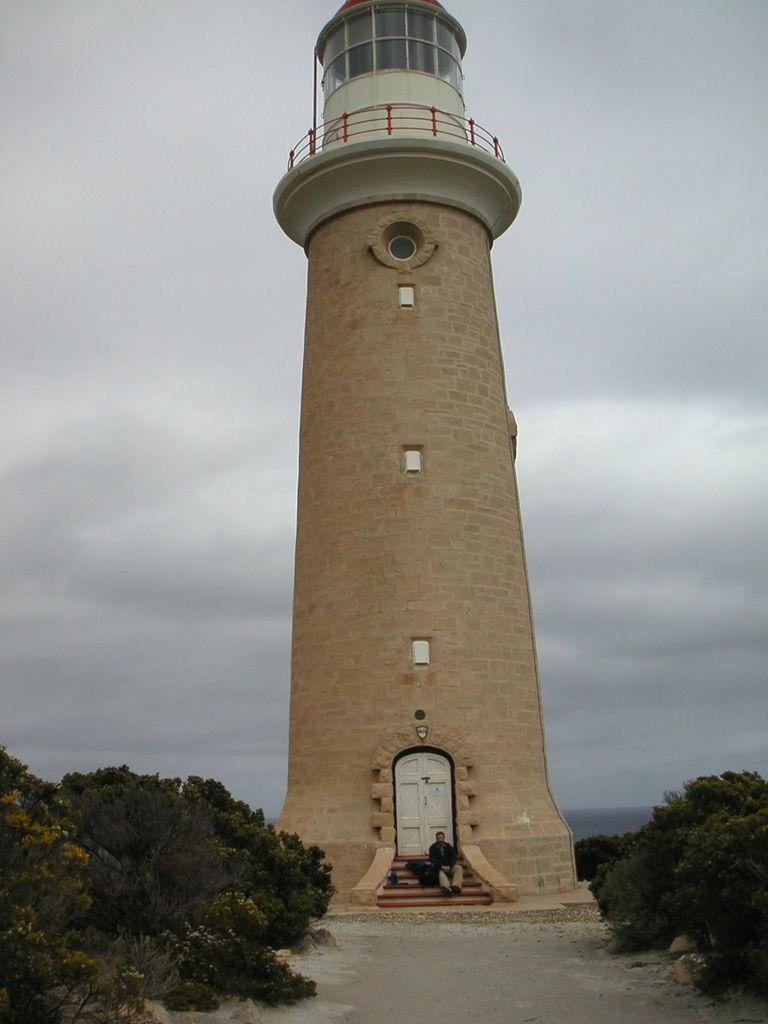What is the color of the lighthouse in the image? The lighthouse in the image is brown. What is the man in the image doing? The man is sitting on the steps in front of the lighthouse. What can be seen at the back of the lighthouse? There is a white door at the back of the lighthouse. What type of vegetation is present near the lighthouse? There are trees on both sides of the lighthouse. What type of breakfast is the man teaching in the image? There is no indication of breakfast or teaching in the image; it features a lighthouse with a man sitting on the steps and trees on both sides. What type of shoes is the man wearing in the image? The image does not show the man's shoes, so it cannot be determined from the image. 